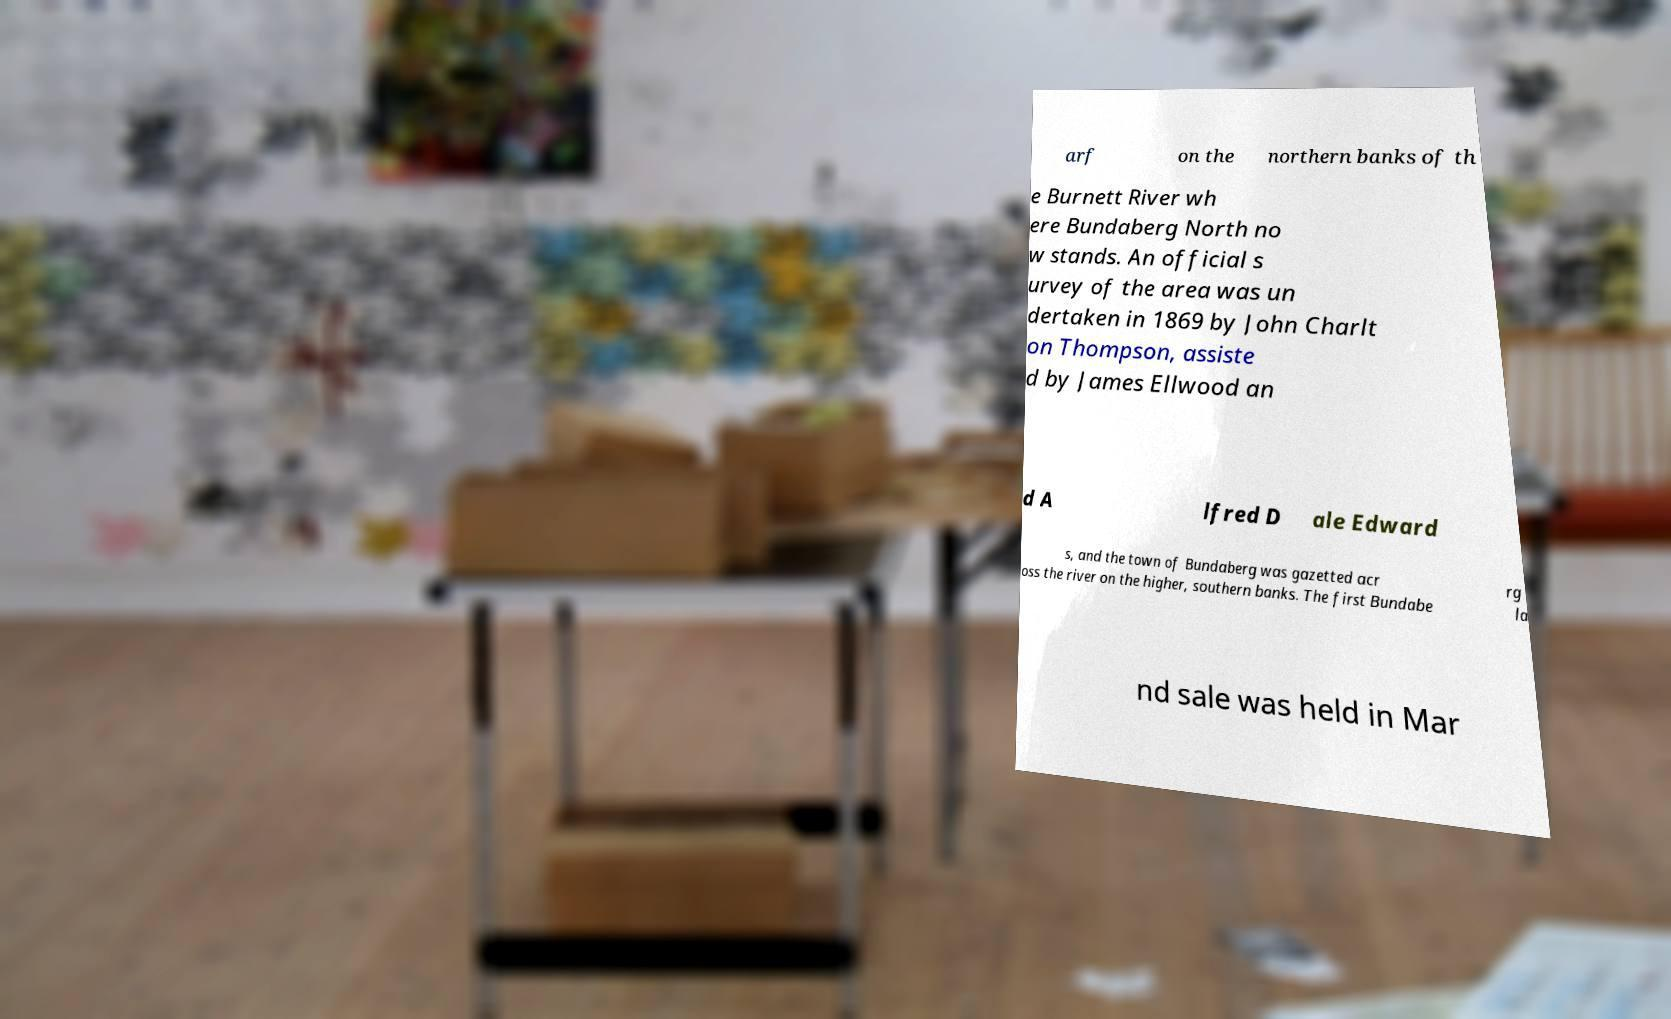Could you assist in decoding the text presented in this image and type it out clearly? arf on the northern banks of th e Burnett River wh ere Bundaberg North no w stands. An official s urvey of the area was un dertaken in 1869 by John Charlt on Thompson, assiste d by James Ellwood an d A lfred D ale Edward s, and the town of Bundaberg was gazetted acr oss the river on the higher, southern banks. The first Bundabe rg la nd sale was held in Mar 